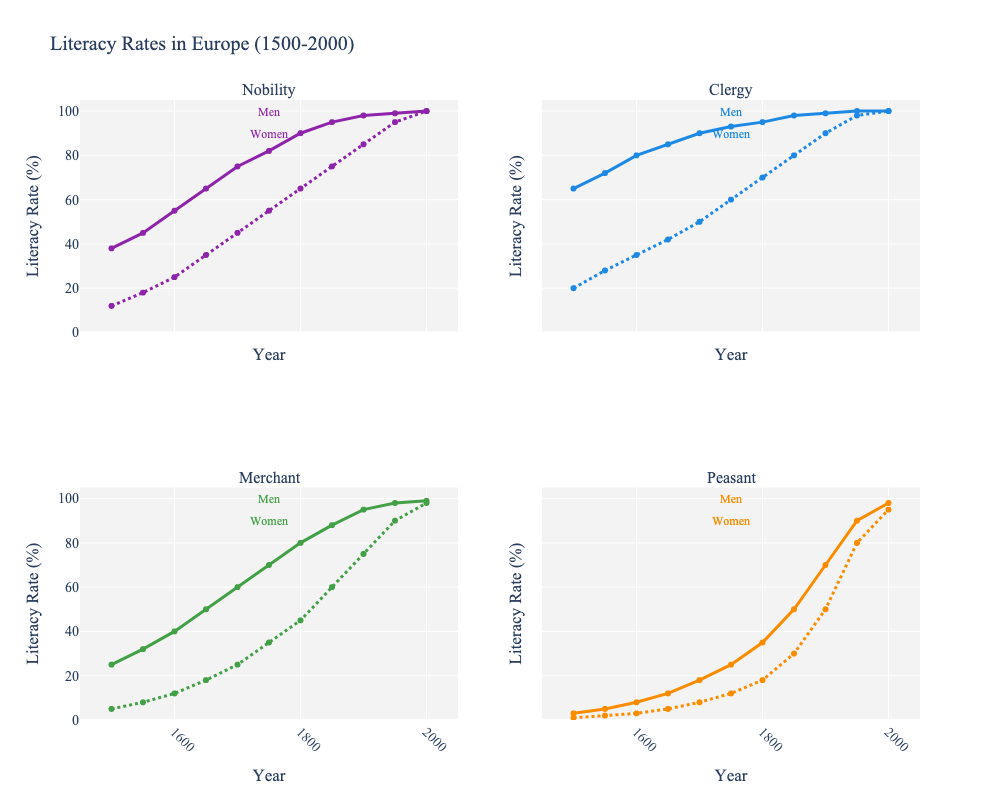What is the difference in literacy rates between Merchant Men and Peasant Men in 1700? In 1700, the literacy rates are 60% for Merchant Men and 18% for Peasant Men. The difference is calculated as 60 - 18.
Answer: 42% How much did the literacy rate for Clergy Women increase from 1500 to 2000? Clergy Women's literacy rates increased from 20% in 1500 to 100% in 2000. The increase is calculated as 100 - 20.
Answer: 80% Which social class showed the greatest improvement in literacy rates for women between 1500 and 2000? Peasant Women increased from 1% in 1500 to 95% in 2000, a 94% increase. No other class had a greater improvement.
Answer: Peasant Women In 1900, which gender had higher literacy rates in the Nobility class and by how much? In 1900, Nobility Men had a literacy rate of 98% and Nobility Women had 85%. The difference is 98 - 85.
Answer: Men by 13% What is the average literacy rate for all classes of men in 1800? The literacy rates in 1800 for men are: Nobility (90%), Clergy (95%), Merchant (80%), and Peasant (35%). The average is calculated as (90 + 95 + 80 + 35) / 4.
Answer: 75% Which group had the lowest literacy rate in 1500 and what was it? In 1500, Peasant Women had the lowest literacy rate, which was 1%.
Answer: Peasant Women, 1% By what year did both Clergy Men and Clergy Women reach literacy rates of 100%? Clergy Men and Clergy Women both reached 100% literacy rates by the year 1950.
Answer: 1950 Compare the literacy rate trends for Nobility Men and Merchant Men between 1550 and 1750. What do you observe? Between 1550 and 1750, Nobility Men's literacy rates increased steadily from 45% to 82%. Merchant Men's literacy rates also rose, but at a slightly faster rate, from 32% to 70%. Both show a steady increase, but the Merchant Men's rate increased more sharply.
Answer: Both increased, Merchant Men faster Which gender had a higher literacy rate in the Peasant class in 1850, and by how much? In 1850, Peasant Men had a literacy rate of 50%, and Peasant Women had 30%. The difference is 50 - 30.
Answer: Men by 20% What's the overall trend in literacy rates for Merchant Women from 1500 to 2000? Literacy rates for Merchant Women steadily increased from 5% in 1500 to 98% in 2000. The trend shows a continuous upward trajectory.
Answer: Upward trajectory 